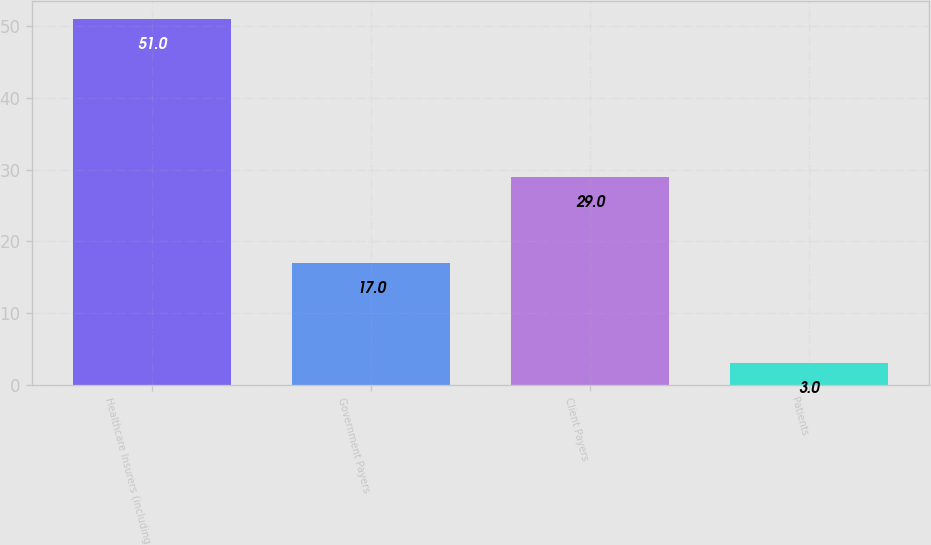Convert chart to OTSL. <chart><loc_0><loc_0><loc_500><loc_500><bar_chart><fcel>Healthcare Insurers (including<fcel>Government Payers<fcel>Client Payers<fcel>Patients<nl><fcel>51<fcel>17<fcel>29<fcel>3<nl></chart> 